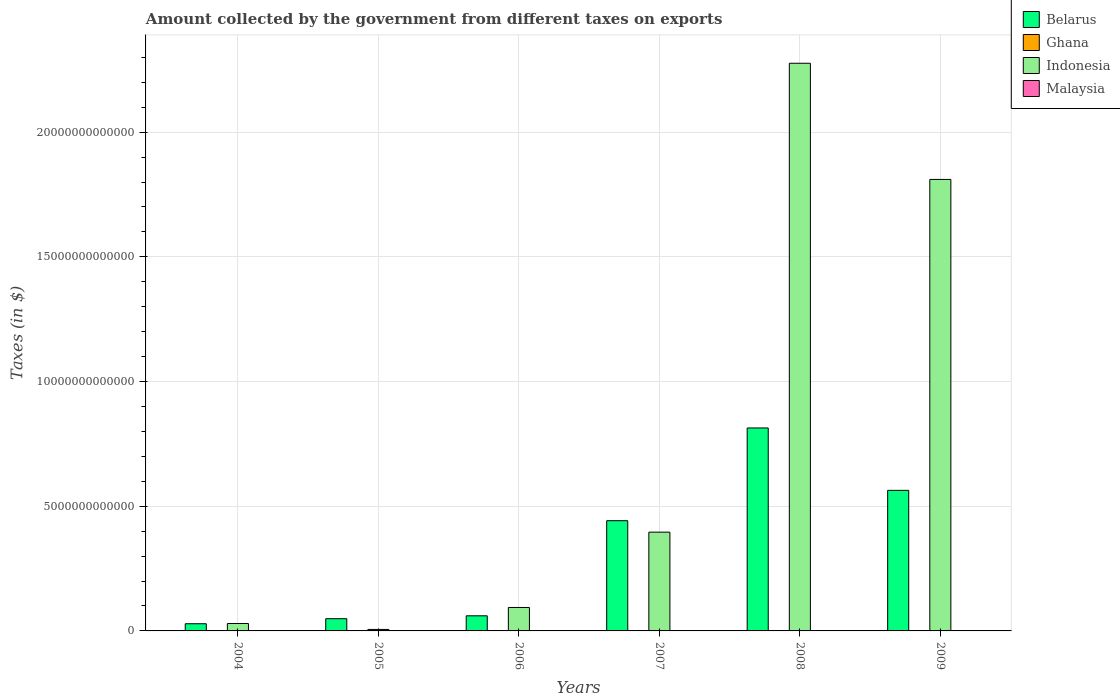Are the number of bars per tick equal to the number of legend labels?
Provide a succinct answer. Yes. Are the number of bars on each tick of the X-axis equal?
Offer a very short reply. Yes. How many bars are there on the 3rd tick from the left?
Your answer should be very brief. 4. How many bars are there on the 3rd tick from the right?
Provide a succinct answer. 4. What is the label of the 5th group of bars from the left?
Your response must be concise. 2008. What is the amount collected by the government from taxes on exports in Indonesia in 2006?
Provide a succinct answer. 9.40e+11. Across all years, what is the maximum amount collected by the government from taxes on exports in Indonesia?
Ensure brevity in your answer.  2.28e+13. Across all years, what is the minimum amount collected by the government from taxes on exports in Malaysia?
Ensure brevity in your answer.  1.15e+09. In which year was the amount collected by the government from taxes on exports in Belarus minimum?
Make the answer very short. 2004. What is the total amount collected by the government from taxes on exports in Ghana in the graph?
Provide a succinct answer. 3.77e+08. What is the difference between the amount collected by the government from taxes on exports in Belarus in 2006 and that in 2009?
Provide a succinct answer. -5.03e+12. What is the difference between the amount collected by the government from taxes on exports in Ghana in 2009 and the amount collected by the government from taxes on exports in Indonesia in 2006?
Keep it short and to the point. -9.40e+11. What is the average amount collected by the government from taxes on exports in Indonesia per year?
Provide a short and direct response. 7.69e+12. In the year 2004, what is the difference between the amount collected by the government from taxes on exports in Ghana and amount collected by the government from taxes on exports in Indonesia?
Offer a very short reply. -2.98e+11. What is the ratio of the amount collected by the government from taxes on exports in Malaysia in 2007 to that in 2008?
Provide a succinct answer. 0.84. Is the difference between the amount collected by the government from taxes on exports in Ghana in 2007 and 2008 greater than the difference between the amount collected by the government from taxes on exports in Indonesia in 2007 and 2008?
Provide a succinct answer. Yes. What is the difference between the highest and the second highest amount collected by the government from taxes on exports in Malaysia?
Give a very brief answer. 4.17e+08. What is the difference between the highest and the lowest amount collected by the government from taxes on exports in Malaysia?
Your response must be concise. 1.63e+09. Is it the case that in every year, the sum of the amount collected by the government from taxes on exports in Malaysia and amount collected by the government from taxes on exports in Indonesia is greater than the sum of amount collected by the government from taxes on exports in Ghana and amount collected by the government from taxes on exports in Belarus?
Offer a terse response. No. What does the 2nd bar from the left in 2009 represents?
Offer a very short reply. Ghana. What is the difference between two consecutive major ticks on the Y-axis?
Offer a terse response. 5.00e+12. Does the graph contain any zero values?
Your answer should be compact. No. Does the graph contain grids?
Ensure brevity in your answer.  Yes. What is the title of the graph?
Your answer should be very brief. Amount collected by the government from different taxes on exports. Does "East Asia (all income levels)" appear as one of the legend labels in the graph?
Offer a terse response. No. What is the label or title of the X-axis?
Your answer should be very brief. Years. What is the label or title of the Y-axis?
Provide a succinct answer. Taxes (in $). What is the Taxes (in $) of Belarus in 2004?
Provide a short and direct response. 2.88e+11. What is the Taxes (in $) of Ghana in 2004?
Keep it short and to the point. 9.86e+07. What is the Taxes (in $) in Indonesia in 2004?
Keep it short and to the point. 2.98e+11. What is the Taxes (in $) in Malaysia in 2004?
Your answer should be compact. 1.60e+09. What is the Taxes (in $) of Belarus in 2005?
Offer a very short reply. 4.90e+11. What is the Taxes (in $) in Ghana in 2005?
Your response must be concise. 6.34e+07. What is the Taxes (in $) in Indonesia in 2005?
Your answer should be compact. 6.00e+1. What is the Taxes (in $) of Malaysia in 2005?
Provide a short and direct response. 2.08e+09. What is the Taxes (in $) of Belarus in 2006?
Offer a terse response. 6.06e+11. What is the Taxes (in $) in Ghana in 2006?
Ensure brevity in your answer.  1.25e+08. What is the Taxes (in $) in Indonesia in 2006?
Ensure brevity in your answer.  9.40e+11. What is the Taxes (in $) in Malaysia in 2006?
Offer a terse response. 2.36e+09. What is the Taxes (in $) of Belarus in 2007?
Your answer should be very brief. 4.42e+12. What is the Taxes (in $) in Ghana in 2007?
Provide a succinct answer. 3.35e+07. What is the Taxes (in $) of Indonesia in 2007?
Ensure brevity in your answer.  3.96e+12. What is the Taxes (in $) of Malaysia in 2007?
Give a very brief answer. 2.32e+09. What is the Taxes (in $) in Belarus in 2008?
Your response must be concise. 8.14e+12. What is the Taxes (in $) of Ghana in 2008?
Your response must be concise. 4.00e+07. What is the Taxes (in $) of Indonesia in 2008?
Offer a very short reply. 2.28e+13. What is the Taxes (in $) in Malaysia in 2008?
Your answer should be very brief. 2.78e+09. What is the Taxes (in $) of Belarus in 2009?
Ensure brevity in your answer.  5.64e+12. What is the Taxes (in $) of Ghana in 2009?
Keep it short and to the point. 1.68e+07. What is the Taxes (in $) in Indonesia in 2009?
Provide a short and direct response. 1.81e+13. What is the Taxes (in $) of Malaysia in 2009?
Provide a succinct answer. 1.15e+09. Across all years, what is the maximum Taxes (in $) in Belarus?
Give a very brief answer. 8.14e+12. Across all years, what is the maximum Taxes (in $) of Ghana?
Provide a short and direct response. 1.25e+08. Across all years, what is the maximum Taxes (in $) of Indonesia?
Your answer should be very brief. 2.28e+13. Across all years, what is the maximum Taxes (in $) in Malaysia?
Your response must be concise. 2.78e+09. Across all years, what is the minimum Taxes (in $) in Belarus?
Keep it short and to the point. 2.88e+11. Across all years, what is the minimum Taxes (in $) in Ghana?
Your response must be concise. 1.68e+07. Across all years, what is the minimum Taxes (in $) of Indonesia?
Keep it short and to the point. 6.00e+1. Across all years, what is the minimum Taxes (in $) in Malaysia?
Provide a short and direct response. 1.15e+09. What is the total Taxes (in $) in Belarus in the graph?
Your answer should be very brief. 1.96e+13. What is the total Taxes (in $) in Ghana in the graph?
Keep it short and to the point. 3.77e+08. What is the total Taxes (in $) in Indonesia in the graph?
Your answer should be very brief. 4.61e+13. What is the total Taxes (in $) in Malaysia in the graph?
Give a very brief answer. 1.23e+1. What is the difference between the Taxes (in $) in Belarus in 2004 and that in 2005?
Your response must be concise. -2.02e+11. What is the difference between the Taxes (in $) of Ghana in 2004 and that in 2005?
Your answer should be compact. 3.51e+07. What is the difference between the Taxes (in $) in Indonesia in 2004 and that in 2005?
Your answer should be very brief. 2.38e+11. What is the difference between the Taxes (in $) of Malaysia in 2004 and that in 2005?
Your response must be concise. -4.85e+08. What is the difference between the Taxes (in $) in Belarus in 2004 and that in 2006?
Your answer should be compact. -3.18e+11. What is the difference between the Taxes (in $) in Ghana in 2004 and that in 2006?
Ensure brevity in your answer.  -2.63e+07. What is the difference between the Taxes (in $) of Indonesia in 2004 and that in 2006?
Offer a very short reply. -6.42e+11. What is the difference between the Taxes (in $) in Malaysia in 2004 and that in 2006?
Provide a short and direct response. -7.62e+08. What is the difference between the Taxes (in $) of Belarus in 2004 and that in 2007?
Your response must be concise. -4.13e+12. What is the difference between the Taxes (in $) in Ghana in 2004 and that in 2007?
Give a very brief answer. 6.51e+07. What is the difference between the Taxes (in $) of Indonesia in 2004 and that in 2007?
Make the answer very short. -3.66e+12. What is the difference between the Taxes (in $) of Malaysia in 2004 and that in 2007?
Offer a very short reply. -7.22e+08. What is the difference between the Taxes (in $) in Belarus in 2004 and that in 2008?
Your response must be concise. -7.85e+12. What is the difference between the Taxes (in $) in Ghana in 2004 and that in 2008?
Provide a succinct answer. 5.86e+07. What is the difference between the Taxes (in $) in Indonesia in 2004 and that in 2008?
Ensure brevity in your answer.  -2.25e+13. What is the difference between the Taxes (in $) of Malaysia in 2004 and that in 2008?
Provide a succinct answer. -1.18e+09. What is the difference between the Taxes (in $) of Belarus in 2004 and that in 2009?
Your response must be concise. -5.35e+12. What is the difference between the Taxes (in $) of Ghana in 2004 and that in 2009?
Your answer should be compact. 8.18e+07. What is the difference between the Taxes (in $) in Indonesia in 2004 and that in 2009?
Offer a terse response. -1.78e+13. What is the difference between the Taxes (in $) of Malaysia in 2004 and that in 2009?
Offer a terse response. 4.48e+08. What is the difference between the Taxes (in $) of Belarus in 2005 and that in 2006?
Your response must be concise. -1.16e+11. What is the difference between the Taxes (in $) of Ghana in 2005 and that in 2006?
Your answer should be compact. -6.14e+07. What is the difference between the Taxes (in $) in Indonesia in 2005 and that in 2006?
Keep it short and to the point. -8.80e+11. What is the difference between the Taxes (in $) of Malaysia in 2005 and that in 2006?
Provide a succinct answer. -2.77e+08. What is the difference between the Taxes (in $) of Belarus in 2005 and that in 2007?
Your answer should be very brief. -3.93e+12. What is the difference between the Taxes (in $) of Ghana in 2005 and that in 2007?
Provide a succinct answer. 2.99e+07. What is the difference between the Taxes (in $) in Indonesia in 2005 and that in 2007?
Keep it short and to the point. -3.90e+12. What is the difference between the Taxes (in $) of Malaysia in 2005 and that in 2007?
Offer a very short reply. -2.37e+08. What is the difference between the Taxes (in $) in Belarus in 2005 and that in 2008?
Give a very brief answer. -7.65e+12. What is the difference between the Taxes (in $) of Ghana in 2005 and that in 2008?
Provide a succinct answer. 2.34e+07. What is the difference between the Taxes (in $) of Indonesia in 2005 and that in 2008?
Keep it short and to the point. -2.27e+13. What is the difference between the Taxes (in $) of Malaysia in 2005 and that in 2008?
Give a very brief answer. -6.94e+08. What is the difference between the Taxes (in $) in Belarus in 2005 and that in 2009?
Make the answer very short. -5.15e+12. What is the difference between the Taxes (in $) of Ghana in 2005 and that in 2009?
Provide a short and direct response. 4.67e+07. What is the difference between the Taxes (in $) of Indonesia in 2005 and that in 2009?
Offer a terse response. -1.80e+13. What is the difference between the Taxes (in $) in Malaysia in 2005 and that in 2009?
Offer a terse response. 9.33e+08. What is the difference between the Taxes (in $) of Belarus in 2006 and that in 2007?
Your answer should be compact. -3.81e+12. What is the difference between the Taxes (in $) of Ghana in 2006 and that in 2007?
Offer a very short reply. 9.13e+07. What is the difference between the Taxes (in $) in Indonesia in 2006 and that in 2007?
Ensure brevity in your answer.  -3.02e+12. What is the difference between the Taxes (in $) in Malaysia in 2006 and that in 2007?
Offer a terse response. 3.92e+07. What is the difference between the Taxes (in $) in Belarus in 2006 and that in 2008?
Offer a very short reply. -7.53e+12. What is the difference between the Taxes (in $) in Ghana in 2006 and that in 2008?
Offer a terse response. 8.49e+07. What is the difference between the Taxes (in $) of Indonesia in 2006 and that in 2008?
Offer a terse response. -2.18e+13. What is the difference between the Taxes (in $) in Malaysia in 2006 and that in 2008?
Your response must be concise. -4.17e+08. What is the difference between the Taxes (in $) of Belarus in 2006 and that in 2009?
Give a very brief answer. -5.03e+12. What is the difference between the Taxes (in $) in Ghana in 2006 and that in 2009?
Offer a very short reply. 1.08e+08. What is the difference between the Taxes (in $) in Indonesia in 2006 and that in 2009?
Your answer should be compact. -1.72e+13. What is the difference between the Taxes (in $) in Malaysia in 2006 and that in 2009?
Give a very brief answer. 1.21e+09. What is the difference between the Taxes (in $) in Belarus in 2007 and that in 2008?
Keep it short and to the point. -3.72e+12. What is the difference between the Taxes (in $) of Ghana in 2007 and that in 2008?
Ensure brevity in your answer.  -6.48e+06. What is the difference between the Taxes (in $) in Indonesia in 2007 and that in 2008?
Ensure brevity in your answer.  -1.88e+13. What is the difference between the Taxes (in $) of Malaysia in 2007 and that in 2008?
Provide a short and direct response. -4.57e+08. What is the difference between the Taxes (in $) in Belarus in 2007 and that in 2009?
Your answer should be compact. -1.22e+12. What is the difference between the Taxes (in $) in Ghana in 2007 and that in 2009?
Ensure brevity in your answer.  1.68e+07. What is the difference between the Taxes (in $) in Indonesia in 2007 and that in 2009?
Your answer should be very brief. -1.41e+13. What is the difference between the Taxes (in $) in Malaysia in 2007 and that in 2009?
Ensure brevity in your answer.  1.17e+09. What is the difference between the Taxes (in $) in Belarus in 2008 and that in 2009?
Provide a succinct answer. 2.50e+12. What is the difference between the Taxes (in $) in Ghana in 2008 and that in 2009?
Your answer should be compact. 2.32e+07. What is the difference between the Taxes (in $) in Indonesia in 2008 and that in 2009?
Provide a short and direct response. 4.66e+12. What is the difference between the Taxes (in $) in Malaysia in 2008 and that in 2009?
Provide a short and direct response. 1.63e+09. What is the difference between the Taxes (in $) in Belarus in 2004 and the Taxes (in $) in Ghana in 2005?
Your answer should be very brief. 2.88e+11. What is the difference between the Taxes (in $) of Belarus in 2004 and the Taxes (in $) of Indonesia in 2005?
Provide a short and direct response. 2.28e+11. What is the difference between the Taxes (in $) of Belarus in 2004 and the Taxes (in $) of Malaysia in 2005?
Your response must be concise. 2.86e+11. What is the difference between the Taxes (in $) of Ghana in 2004 and the Taxes (in $) of Indonesia in 2005?
Offer a terse response. -5.99e+1. What is the difference between the Taxes (in $) of Ghana in 2004 and the Taxes (in $) of Malaysia in 2005?
Keep it short and to the point. -1.99e+09. What is the difference between the Taxes (in $) of Indonesia in 2004 and the Taxes (in $) of Malaysia in 2005?
Keep it short and to the point. 2.96e+11. What is the difference between the Taxes (in $) of Belarus in 2004 and the Taxes (in $) of Ghana in 2006?
Make the answer very short. 2.88e+11. What is the difference between the Taxes (in $) in Belarus in 2004 and the Taxes (in $) in Indonesia in 2006?
Make the answer very short. -6.52e+11. What is the difference between the Taxes (in $) in Belarus in 2004 and the Taxes (in $) in Malaysia in 2006?
Your response must be concise. 2.86e+11. What is the difference between the Taxes (in $) of Ghana in 2004 and the Taxes (in $) of Indonesia in 2006?
Your answer should be very brief. -9.40e+11. What is the difference between the Taxes (in $) in Ghana in 2004 and the Taxes (in $) in Malaysia in 2006?
Keep it short and to the point. -2.26e+09. What is the difference between the Taxes (in $) of Indonesia in 2004 and the Taxes (in $) of Malaysia in 2006?
Keep it short and to the point. 2.95e+11. What is the difference between the Taxes (in $) in Belarus in 2004 and the Taxes (in $) in Ghana in 2007?
Ensure brevity in your answer.  2.88e+11. What is the difference between the Taxes (in $) in Belarus in 2004 and the Taxes (in $) in Indonesia in 2007?
Provide a succinct answer. -3.67e+12. What is the difference between the Taxes (in $) in Belarus in 2004 and the Taxes (in $) in Malaysia in 2007?
Keep it short and to the point. 2.86e+11. What is the difference between the Taxes (in $) of Ghana in 2004 and the Taxes (in $) of Indonesia in 2007?
Give a very brief answer. -3.96e+12. What is the difference between the Taxes (in $) of Ghana in 2004 and the Taxes (in $) of Malaysia in 2007?
Offer a very short reply. -2.22e+09. What is the difference between the Taxes (in $) of Indonesia in 2004 and the Taxes (in $) of Malaysia in 2007?
Offer a very short reply. 2.95e+11. What is the difference between the Taxes (in $) in Belarus in 2004 and the Taxes (in $) in Ghana in 2008?
Ensure brevity in your answer.  2.88e+11. What is the difference between the Taxes (in $) in Belarus in 2004 and the Taxes (in $) in Indonesia in 2008?
Provide a succinct answer. -2.25e+13. What is the difference between the Taxes (in $) in Belarus in 2004 and the Taxes (in $) in Malaysia in 2008?
Your response must be concise. 2.85e+11. What is the difference between the Taxes (in $) of Ghana in 2004 and the Taxes (in $) of Indonesia in 2008?
Offer a terse response. -2.28e+13. What is the difference between the Taxes (in $) in Ghana in 2004 and the Taxes (in $) in Malaysia in 2008?
Ensure brevity in your answer.  -2.68e+09. What is the difference between the Taxes (in $) of Indonesia in 2004 and the Taxes (in $) of Malaysia in 2008?
Your answer should be compact. 2.95e+11. What is the difference between the Taxes (in $) in Belarus in 2004 and the Taxes (in $) in Ghana in 2009?
Ensure brevity in your answer.  2.88e+11. What is the difference between the Taxes (in $) in Belarus in 2004 and the Taxes (in $) in Indonesia in 2009?
Ensure brevity in your answer.  -1.78e+13. What is the difference between the Taxes (in $) in Belarus in 2004 and the Taxes (in $) in Malaysia in 2009?
Provide a short and direct response. 2.87e+11. What is the difference between the Taxes (in $) in Ghana in 2004 and the Taxes (in $) in Indonesia in 2009?
Your answer should be compact. -1.81e+13. What is the difference between the Taxes (in $) of Ghana in 2004 and the Taxes (in $) of Malaysia in 2009?
Your answer should be very brief. -1.05e+09. What is the difference between the Taxes (in $) of Indonesia in 2004 and the Taxes (in $) of Malaysia in 2009?
Keep it short and to the point. 2.97e+11. What is the difference between the Taxes (in $) in Belarus in 2005 and the Taxes (in $) in Ghana in 2006?
Your answer should be compact. 4.90e+11. What is the difference between the Taxes (in $) in Belarus in 2005 and the Taxes (in $) in Indonesia in 2006?
Make the answer very short. -4.50e+11. What is the difference between the Taxes (in $) in Belarus in 2005 and the Taxes (in $) in Malaysia in 2006?
Make the answer very short. 4.88e+11. What is the difference between the Taxes (in $) of Ghana in 2005 and the Taxes (in $) of Indonesia in 2006?
Your response must be concise. -9.40e+11. What is the difference between the Taxes (in $) of Ghana in 2005 and the Taxes (in $) of Malaysia in 2006?
Keep it short and to the point. -2.30e+09. What is the difference between the Taxes (in $) of Indonesia in 2005 and the Taxes (in $) of Malaysia in 2006?
Your answer should be very brief. 5.77e+1. What is the difference between the Taxes (in $) in Belarus in 2005 and the Taxes (in $) in Ghana in 2007?
Offer a terse response. 4.90e+11. What is the difference between the Taxes (in $) in Belarus in 2005 and the Taxes (in $) in Indonesia in 2007?
Provide a short and direct response. -3.47e+12. What is the difference between the Taxes (in $) in Belarus in 2005 and the Taxes (in $) in Malaysia in 2007?
Your answer should be very brief. 4.88e+11. What is the difference between the Taxes (in $) in Ghana in 2005 and the Taxes (in $) in Indonesia in 2007?
Your answer should be compact. -3.96e+12. What is the difference between the Taxes (in $) of Ghana in 2005 and the Taxes (in $) of Malaysia in 2007?
Make the answer very short. -2.26e+09. What is the difference between the Taxes (in $) of Indonesia in 2005 and the Taxes (in $) of Malaysia in 2007?
Provide a short and direct response. 5.77e+1. What is the difference between the Taxes (in $) in Belarus in 2005 and the Taxes (in $) in Ghana in 2008?
Your response must be concise. 4.90e+11. What is the difference between the Taxes (in $) in Belarus in 2005 and the Taxes (in $) in Indonesia in 2008?
Offer a terse response. -2.23e+13. What is the difference between the Taxes (in $) in Belarus in 2005 and the Taxes (in $) in Malaysia in 2008?
Give a very brief answer. 4.88e+11. What is the difference between the Taxes (in $) in Ghana in 2005 and the Taxes (in $) in Indonesia in 2008?
Make the answer very short. -2.28e+13. What is the difference between the Taxes (in $) in Ghana in 2005 and the Taxes (in $) in Malaysia in 2008?
Offer a terse response. -2.72e+09. What is the difference between the Taxes (in $) in Indonesia in 2005 and the Taxes (in $) in Malaysia in 2008?
Keep it short and to the point. 5.72e+1. What is the difference between the Taxes (in $) in Belarus in 2005 and the Taxes (in $) in Ghana in 2009?
Offer a very short reply. 4.90e+11. What is the difference between the Taxes (in $) in Belarus in 2005 and the Taxes (in $) in Indonesia in 2009?
Offer a terse response. -1.76e+13. What is the difference between the Taxes (in $) of Belarus in 2005 and the Taxes (in $) of Malaysia in 2009?
Provide a succinct answer. 4.89e+11. What is the difference between the Taxes (in $) of Ghana in 2005 and the Taxes (in $) of Indonesia in 2009?
Give a very brief answer. -1.81e+13. What is the difference between the Taxes (in $) in Ghana in 2005 and the Taxes (in $) in Malaysia in 2009?
Provide a succinct answer. -1.09e+09. What is the difference between the Taxes (in $) in Indonesia in 2005 and the Taxes (in $) in Malaysia in 2009?
Provide a short and direct response. 5.89e+1. What is the difference between the Taxes (in $) of Belarus in 2006 and the Taxes (in $) of Ghana in 2007?
Ensure brevity in your answer.  6.06e+11. What is the difference between the Taxes (in $) in Belarus in 2006 and the Taxes (in $) in Indonesia in 2007?
Keep it short and to the point. -3.35e+12. What is the difference between the Taxes (in $) of Belarus in 2006 and the Taxes (in $) of Malaysia in 2007?
Keep it short and to the point. 6.04e+11. What is the difference between the Taxes (in $) in Ghana in 2006 and the Taxes (in $) in Indonesia in 2007?
Your answer should be compact. -3.96e+12. What is the difference between the Taxes (in $) of Ghana in 2006 and the Taxes (in $) of Malaysia in 2007?
Your response must be concise. -2.20e+09. What is the difference between the Taxes (in $) of Indonesia in 2006 and the Taxes (in $) of Malaysia in 2007?
Ensure brevity in your answer.  9.38e+11. What is the difference between the Taxes (in $) in Belarus in 2006 and the Taxes (in $) in Ghana in 2008?
Make the answer very short. 6.06e+11. What is the difference between the Taxes (in $) in Belarus in 2006 and the Taxes (in $) in Indonesia in 2008?
Provide a short and direct response. -2.22e+13. What is the difference between the Taxes (in $) of Belarus in 2006 and the Taxes (in $) of Malaysia in 2008?
Provide a succinct answer. 6.03e+11. What is the difference between the Taxes (in $) of Ghana in 2006 and the Taxes (in $) of Indonesia in 2008?
Your answer should be very brief. -2.28e+13. What is the difference between the Taxes (in $) of Ghana in 2006 and the Taxes (in $) of Malaysia in 2008?
Provide a short and direct response. -2.65e+09. What is the difference between the Taxes (in $) of Indonesia in 2006 and the Taxes (in $) of Malaysia in 2008?
Offer a terse response. 9.37e+11. What is the difference between the Taxes (in $) in Belarus in 2006 and the Taxes (in $) in Ghana in 2009?
Ensure brevity in your answer.  6.06e+11. What is the difference between the Taxes (in $) of Belarus in 2006 and the Taxes (in $) of Indonesia in 2009?
Your answer should be very brief. -1.75e+13. What is the difference between the Taxes (in $) in Belarus in 2006 and the Taxes (in $) in Malaysia in 2009?
Your response must be concise. 6.05e+11. What is the difference between the Taxes (in $) of Ghana in 2006 and the Taxes (in $) of Indonesia in 2009?
Keep it short and to the point. -1.81e+13. What is the difference between the Taxes (in $) in Ghana in 2006 and the Taxes (in $) in Malaysia in 2009?
Your response must be concise. -1.03e+09. What is the difference between the Taxes (in $) of Indonesia in 2006 and the Taxes (in $) of Malaysia in 2009?
Offer a very short reply. 9.39e+11. What is the difference between the Taxes (in $) in Belarus in 2007 and the Taxes (in $) in Ghana in 2008?
Give a very brief answer. 4.42e+12. What is the difference between the Taxes (in $) of Belarus in 2007 and the Taxes (in $) of Indonesia in 2008?
Your response must be concise. -1.83e+13. What is the difference between the Taxes (in $) in Belarus in 2007 and the Taxes (in $) in Malaysia in 2008?
Your answer should be compact. 4.42e+12. What is the difference between the Taxes (in $) in Ghana in 2007 and the Taxes (in $) in Indonesia in 2008?
Keep it short and to the point. -2.28e+13. What is the difference between the Taxes (in $) in Ghana in 2007 and the Taxes (in $) in Malaysia in 2008?
Your answer should be very brief. -2.75e+09. What is the difference between the Taxes (in $) of Indonesia in 2007 and the Taxes (in $) of Malaysia in 2008?
Keep it short and to the point. 3.96e+12. What is the difference between the Taxes (in $) of Belarus in 2007 and the Taxes (in $) of Ghana in 2009?
Keep it short and to the point. 4.42e+12. What is the difference between the Taxes (in $) in Belarus in 2007 and the Taxes (in $) in Indonesia in 2009?
Make the answer very short. -1.37e+13. What is the difference between the Taxes (in $) of Belarus in 2007 and the Taxes (in $) of Malaysia in 2009?
Keep it short and to the point. 4.42e+12. What is the difference between the Taxes (in $) in Ghana in 2007 and the Taxes (in $) in Indonesia in 2009?
Provide a succinct answer. -1.81e+13. What is the difference between the Taxes (in $) in Ghana in 2007 and the Taxes (in $) in Malaysia in 2009?
Give a very brief answer. -1.12e+09. What is the difference between the Taxes (in $) of Indonesia in 2007 and the Taxes (in $) of Malaysia in 2009?
Your answer should be compact. 3.96e+12. What is the difference between the Taxes (in $) of Belarus in 2008 and the Taxes (in $) of Ghana in 2009?
Make the answer very short. 8.14e+12. What is the difference between the Taxes (in $) in Belarus in 2008 and the Taxes (in $) in Indonesia in 2009?
Offer a terse response. -9.97e+12. What is the difference between the Taxes (in $) in Belarus in 2008 and the Taxes (in $) in Malaysia in 2009?
Provide a short and direct response. 8.14e+12. What is the difference between the Taxes (in $) of Ghana in 2008 and the Taxes (in $) of Indonesia in 2009?
Your answer should be compact. -1.81e+13. What is the difference between the Taxes (in $) of Ghana in 2008 and the Taxes (in $) of Malaysia in 2009?
Make the answer very short. -1.11e+09. What is the difference between the Taxes (in $) of Indonesia in 2008 and the Taxes (in $) of Malaysia in 2009?
Offer a terse response. 2.28e+13. What is the average Taxes (in $) of Belarus per year?
Your answer should be compact. 3.26e+12. What is the average Taxes (in $) of Ghana per year?
Offer a terse response. 6.29e+07. What is the average Taxes (in $) in Indonesia per year?
Offer a very short reply. 7.69e+12. What is the average Taxes (in $) of Malaysia per year?
Make the answer very short. 2.05e+09. In the year 2004, what is the difference between the Taxes (in $) of Belarus and Taxes (in $) of Ghana?
Keep it short and to the point. 2.88e+11. In the year 2004, what is the difference between the Taxes (in $) of Belarus and Taxes (in $) of Indonesia?
Keep it short and to the point. -9.70e+09. In the year 2004, what is the difference between the Taxes (in $) of Belarus and Taxes (in $) of Malaysia?
Give a very brief answer. 2.87e+11. In the year 2004, what is the difference between the Taxes (in $) in Ghana and Taxes (in $) in Indonesia?
Provide a succinct answer. -2.98e+11. In the year 2004, what is the difference between the Taxes (in $) of Ghana and Taxes (in $) of Malaysia?
Ensure brevity in your answer.  -1.50e+09. In the year 2004, what is the difference between the Taxes (in $) of Indonesia and Taxes (in $) of Malaysia?
Provide a short and direct response. 2.96e+11. In the year 2005, what is the difference between the Taxes (in $) of Belarus and Taxes (in $) of Ghana?
Provide a short and direct response. 4.90e+11. In the year 2005, what is the difference between the Taxes (in $) in Belarus and Taxes (in $) in Indonesia?
Give a very brief answer. 4.30e+11. In the year 2005, what is the difference between the Taxes (in $) of Belarus and Taxes (in $) of Malaysia?
Your response must be concise. 4.88e+11. In the year 2005, what is the difference between the Taxes (in $) in Ghana and Taxes (in $) in Indonesia?
Provide a succinct answer. -6.00e+1. In the year 2005, what is the difference between the Taxes (in $) of Ghana and Taxes (in $) of Malaysia?
Keep it short and to the point. -2.02e+09. In the year 2005, what is the difference between the Taxes (in $) in Indonesia and Taxes (in $) in Malaysia?
Make the answer very short. 5.79e+1. In the year 2006, what is the difference between the Taxes (in $) in Belarus and Taxes (in $) in Ghana?
Provide a short and direct response. 6.06e+11. In the year 2006, what is the difference between the Taxes (in $) in Belarus and Taxes (in $) in Indonesia?
Make the answer very short. -3.34e+11. In the year 2006, what is the difference between the Taxes (in $) in Belarus and Taxes (in $) in Malaysia?
Your answer should be very brief. 6.04e+11. In the year 2006, what is the difference between the Taxes (in $) in Ghana and Taxes (in $) in Indonesia?
Your answer should be compact. -9.40e+11. In the year 2006, what is the difference between the Taxes (in $) in Ghana and Taxes (in $) in Malaysia?
Ensure brevity in your answer.  -2.24e+09. In the year 2006, what is the difference between the Taxes (in $) in Indonesia and Taxes (in $) in Malaysia?
Ensure brevity in your answer.  9.38e+11. In the year 2007, what is the difference between the Taxes (in $) of Belarus and Taxes (in $) of Ghana?
Your answer should be compact. 4.42e+12. In the year 2007, what is the difference between the Taxes (in $) in Belarus and Taxes (in $) in Indonesia?
Offer a very short reply. 4.59e+11. In the year 2007, what is the difference between the Taxes (in $) of Belarus and Taxes (in $) of Malaysia?
Give a very brief answer. 4.42e+12. In the year 2007, what is the difference between the Taxes (in $) in Ghana and Taxes (in $) in Indonesia?
Provide a short and direct response. -3.96e+12. In the year 2007, what is the difference between the Taxes (in $) of Ghana and Taxes (in $) of Malaysia?
Your answer should be compact. -2.29e+09. In the year 2007, what is the difference between the Taxes (in $) in Indonesia and Taxes (in $) in Malaysia?
Provide a succinct answer. 3.96e+12. In the year 2008, what is the difference between the Taxes (in $) in Belarus and Taxes (in $) in Ghana?
Provide a short and direct response. 8.14e+12. In the year 2008, what is the difference between the Taxes (in $) in Belarus and Taxes (in $) in Indonesia?
Offer a very short reply. -1.46e+13. In the year 2008, what is the difference between the Taxes (in $) in Belarus and Taxes (in $) in Malaysia?
Offer a terse response. 8.14e+12. In the year 2008, what is the difference between the Taxes (in $) in Ghana and Taxes (in $) in Indonesia?
Offer a very short reply. -2.28e+13. In the year 2008, what is the difference between the Taxes (in $) in Ghana and Taxes (in $) in Malaysia?
Your answer should be compact. -2.74e+09. In the year 2008, what is the difference between the Taxes (in $) in Indonesia and Taxes (in $) in Malaysia?
Offer a terse response. 2.28e+13. In the year 2009, what is the difference between the Taxes (in $) in Belarus and Taxes (in $) in Ghana?
Give a very brief answer. 5.64e+12. In the year 2009, what is the difference between the Taxes (in $) in Belarus and Taxes (in $) in Indonesia?
Ensure brevity in your answer.  -1.25e+13. In the year 2009, what is the difference between the Taxes (in $) in Belarus and Taxes (in $) in Malaysia?
Your answer should be compact. 5.64e+12. In the year 2009, what is the difference between the Taxes (in $) in Ghana and Taxes (in $) in Indonesia?
Ensure brevity in your answer.  -1.81e+13. In the year 2009, what is the difference between the Taxes (in $) in Ghana and Taxes (in $) in Malaysia?
Your response must be concise. -1.14e+09. In the year 2009, what is the difference between the Taxes (in $) in Indonesia and Taxes (in $) in Malaysia?
Offer a very short reply. 1.81e+13. What is the ratio of the Taxes (in $) of Belarus in 2004 to that in 2005?
Provide a short and direct response. 0.59. What is the ratio of the Taxes (in $) of Ghana in 2004 to that in 2005?
Provide a succinct answer. 1.55. What is the ratio of the Taxes (in $) in Indonesia in 2004 to that in 2005?
Make the answer very short. 4.96. What is the ratio of the Taxes (in $) in Malaysia in 2004 to that in 2005?
Ensure brevity in your answer.  0.77. What is the ratio of the Taxes (in $) of Belarus in 2004 to that in 2006?
Keep it short and to the point. 0.48. What is the ratio of the Taxes (in $) in Ghana in 2004 to that in 2006?
Make the answer very short. 0.79. What is the ratio of the Taxes (in $) of Indonesia in 2004 to that in 2006?
Ensure brevity in your answer.  0.32. What is the ratio of the Taxes (in $) in Malaysia in 2004 to that in 2006?
Offer a very short reply. 0.68. What is the ratio of the Taxes (in $) in Belarus in 2004 to that in 2007?
Your answer should be compact. 0.07. What is the ratio of the Taxes (in $) of Ghana in 2004 to that in 2007?
Provide a short and direct response. 2.94. What is the ratio of the Taxes (in $) of Indonesia in 2004 to that in 2007?
Provide a short and direct response. 0.08. What is the ratio of the Taxes (in $) of Malaysia in 2004 to that in 2007?
Your answer should be compact. 0.69. What is the ratio of the Taxes (in $) in Belarus in 2004 to that in 2008?
Give a very brief answer. 0.04. What is the ratio of the Taxes (in $) in Ghana in 2004 to that in 2008?
Offer a very short reply. 2.46. What is the ratio of the Taxes (in $) in Indonesia in 2004 to that in 2008?
Offer a terse response. 0.01. What is the ratio of the Taxes (in $) of Malaysia in 2004 to that in 2008?
Keep it short and to the point. 0.58. What is the ratio of the Taxes (in $) of Belarus in 2004 to that in 2009?
Make the answer very short. 0.05. What is the ratio of the Taxes (in $) of Ghana in 2004 to that in 2009?
Provide a short and direct response. 5.88. What is the ratio of the Taxes (in $) of Indonesia in 2004 to that in 2009?
Provide a succinct answer. 0.02. What is the ratio of the Taxes (in $) in Malaysia in 2004 to that in 2009?
Ensure brevity in your answer.  1.39. What is the ratio of the Taxes (in $) in Belarus in 2005 to that in 2006?
Your answer should be very brief. 0.81. What is the ratio of the Taxes (in $) of Ghana in 2005 to that in 2006?
Give a very brief answer. 0.51. What is the ratio of the Taxes (in $) in Indonesia in 2005 to that in 2006?
Offer a very short reply. 0.06. What is the ratio of the Taxes (in $) of Malaysia in 2005 to that in 2006?
Provide a short and direct response. 0.88. What is the ratio of the Taxes (in $) in Belarus in 2005 to that in 2007?
Your answer should be compact. 0.11. What is the ratio of the Taxes (in $) of Ghana in 2005 to that in 2007?
Make the answer very short. 1.89. What is the ratio of the Taxes (in $) of Indonesia in 2005 to that in 2007?
Give a very brief answer. 0.02. What is the ratio of the Taxes (in $) in Malaysia in 2005 to that in 2007?
Keep it short and to the point. 0.9. What is the ratio of the Taxes (in $) of Belarus in 2005 to that in 2008?
Offer a terse response. 0.06. What is the ratio of the Taxes (in $) of Ghana in 2005 to that in 2008?
Offer a terse response. 1.59. What is the ratio of the Taxes (in $) of Indonesia in 2005 to that in 2008?
Ensure brevity in your answer.  0. What is the ratio of the Taxes (in $) of Malaysia in 2005 to that in 2008?
Your answer should be very brief. 0.75. What is the ratio of the Taxes (in $) in Belarus in 2005 to that in 2009?
Offer a very short reply. 0.09. What is the ratio of the Taxes (in $) in Ghana in 2005 to that in 2009?
Provide a succinct answer. 3.79. What is the ratio of the Taxes (in $) in Indonesia in 2005 to that in 2009?
Keep it short and to the point. 0. What is the ratio of the Taxes (in $) in Malaysia in 2005 to that in 2009?
Your answer should be compact. 1.81. What is the ratio of the Taxes (in $) of Belarus in 2006 to that in 2007?
Keep it short and to the point. 0.14. What is the ratio of the Taxes (in $) in Ghana in 2006 to that in 2007?
Give a very brief answer. 3.72. What is the ratio of the Taxes (in $) in Indonesia in 2006 to that in 2007?
Your response must be concise. 0.24. What is the ratio of the Taxes (in $) of Malaysia in 2006 to that in 2007?
Ensure brevity in your answer.  1.02. What is the ratio of the Taxes (in $) in Belarus in 2006 to that in 2008?
Your answer should be compact. 0.07. What is the ratio of the Taxes (in $) in Ghana in 2006 to that in 2008?
Give a very brief answer. 3.12. What is the ratio of the Taxes (in $) of Indonesia in 2006 to that in 2008?
Give a very brief answer. 0.04. What is the ratio of the Taxes (in $) in Malaysia in 2006 to that in 2008?
Offer a terse response. 0.85. What is the ratio of the Taxes (in $) in Belarus in 2006 to that in 2009?
Offer a terse response. 0.11. What is the ratio of the Taxes (in $) in Ghana in 2006 to that in 2009?
Offer a terse response. 7.45. What is the ratio of the Taxes (in $) in Indonesia in 2006 to that in 2009?
Your response must be concise. 0.05. What is the ratio of the Taxes (in $) in Malaysia in 2006 to that in 2009?
Your answer should be very brief. 2.05. What is the ratio of the Taxes (in $) in Belarus in 2007 to that in 2008?
Provide a succinct answer. 0.54. What is the ratio of the Taxes (in $) in Ghana in 2007 to that in 2008?
Ensure brevity in your answer.  0.84. What is the ratio of the Taxes (in $) of Indonesia in 2007 to that in 2008?
Make the answer very short. 0.17. What is the ratio of the Taxes (in $) in Malaysia in 2007 to that in 2008?
Provide a succinct answer. 0.84. What is the ratio of the Taxes (in $) of Belarus in 2007 to that in 2009?
Your answer should be very brief. 0.78. What is the ratio of the Taxes (in $) of Ghana in 2007 to that in 2009?
Your answer should be compact. 2. What is the ratio of the Taxes (in $) of Indonesia in 2007 to that in 2009?
Your answer should be compact. 0.22. What is the ratio of the Taxes (in $) of Malaysia in 2007 to that in 2009?
Offer a very short reply. 2.02. What is the ratio of the Taxes (in $) of Belarus in 2008 to that in 2009?
Your response must be concise. 1.44. What is the ratio of the Taxes (in $) of Ghana in 2008 to that in 2009?
Your answer should be very brief. 2.39. What is the ratio of the Taxes (in $) in Indonesia in 2008 to that in 2009?
Offer a terse response. 1.26. What is the ratio of the Taxes (in $) of Malaysia in 2008 to that in 2009?
Your response must be concise. 2.41. What is the difference between the highest and the second highest Taxes (in $) in Belarus?
Keep it short and to the point. 2.50e+12. What is the difference between the highest and the second highest Taxes (in $) in Ghana?
Provide a succinct answer. 2.63e+07. What is the difference between the highest and the second highest Taxes (in $) in Indonesia?
Give a very brief answer. 4.66e+12. What is the difference between the highest and the second highest Taxes (in $) in Malaysia?
Offer a very short reply. 4.17e+08. What is the difference between the highest and the lowest Taxes (in $) of Belarus?
Your answer should be very brief. 7.85e+12. What is the difference between the highest and the lowest Taxes (in $) of Ghana?
Your answer should be compact. 1.08e+08. What is the difference between the highest and the lowest Taxes (in $) of Indonesia?
Your answer should be compact. 2.27e+13. What is the difference between the highest and the lowest Taxes (in $) of Malaysia?
Offer a terse response. 1.63e+09. 